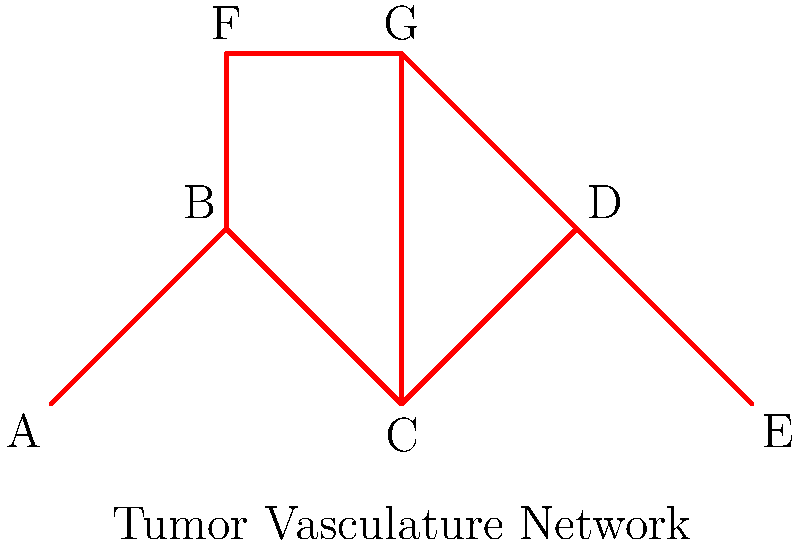Consider the tumor vasculature network shown above. Assuming each edge represents a blood vessel and each vertex represents a branching point, calculate the first homology group $H_1$ of this network. How many independent loops does this network contain, and what does this imply about the network's ability to maintain blood flow in case of vessel blockage? To calculate the first homology group $H_1$ and determine the number of independent loops in this tumor vasculature network, we'll follow these steps:

1. Count the number of vertices (V): There are 7 vertices (A, B, C, D, E, F, G).

2. Count the number of edges (E): There are 8 edges connecting the vertices.

3. Count the number of connected components (C): The network is fully connected, so C = 1.

4. Calculate the first Betti number $\beta_1$, which is equal to the rank of $H_1$:
   $\beta_1 = E - V + C = 8 - 7 + 1 = 2$

5. The first Betti number $\beta_1 = 2$ indicates that there are two independent loops in the network.

6. Identify the loops:
   Loop 1: B-C-D-B
   Loop 2: B-F-G-C-B

7. Implications for blood flow:
   The presence of two independent loops suggests redundancy in the network. If one vessel is blocked, blood can still flow through alternative paths, maintaining perfusion to the tumor tissue. This redundancy makes the tumor vasculature more resilient to interventions aimed at disrupting blood supply.

8. From an oncologist's perspective critical of the pharmaceutical industry:
   This topological feature of tumor vasculature networks highlights the challenges in developing effective anti-angiogenic therapies. The redundancy in blood flow pathways may explain why some anti-angiogenic drugs have shown limited efficacy in clinical trials, despite promising preclinical results.
Answer: $H_1 \cong \mathbb{Z}^2$; 2 independent loops; increased resilience to vessel blockage 